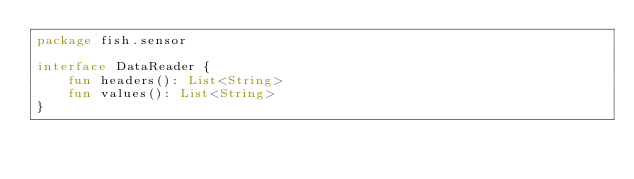Convert code to text. <code><loc_0><loc_0><loc_500><loc_500><_Kotlin_>package fish.sensor

interface DataReader {
    fun headers(): List<String>
    fun values(): List<String>
}</code> 